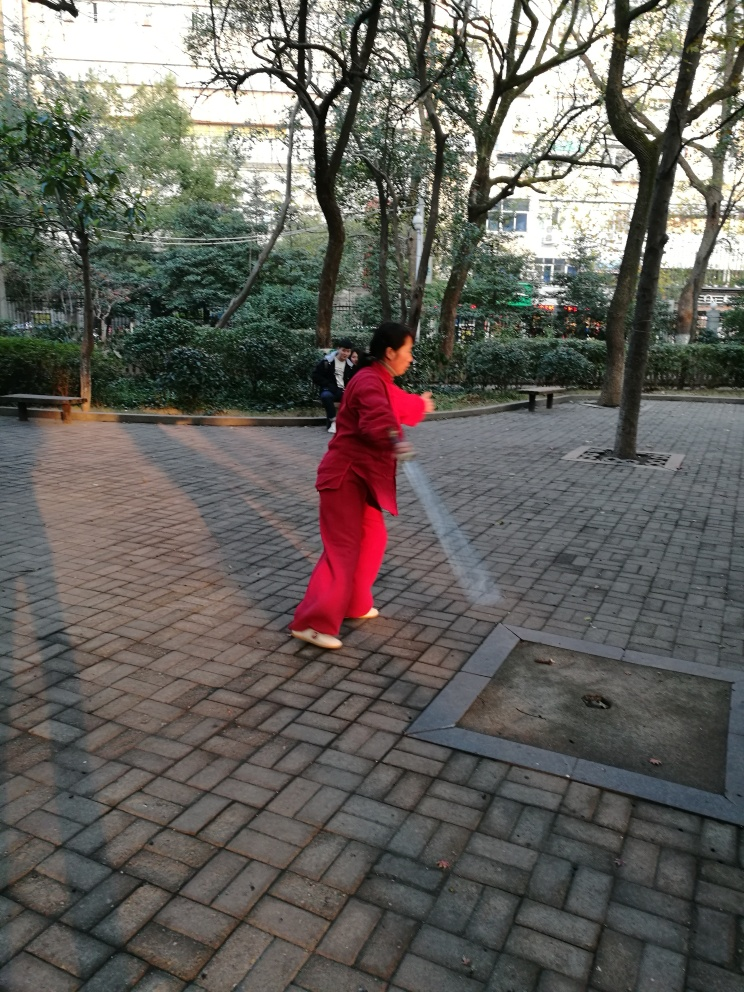Are the main subjects clear in the image? While the main subject, a person wearing red attire, is relatively clear and becomes the focal point due to their vibrant clothing and motion, there are elements such as blurriness and background distractions that might detract from its clarity. Therefore, I would grade the image clarity as generally clear but with some noted deficiencies that affect the overall sharpness of the subject. 